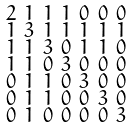Convert formula to latex. <formula><loc_0><loc_0><loc_500><loc_500>\begin{smallmatrix} 2 & 1 & 1 & 1 & 0 & 0 & 0 \\ 1 & 3 & 1 & 1 & 1 & 1 & 1 \\ 1 & 1 & 3 & 0 & 1 & 1 & 0 \\ 1 & 1 & 0 & 3 & 0 & 0 & 0 \\ 0 & 1 & 1 & 0 & 3 & 0 & 0 \\ 0 & 1 & 1 & 0 & 0 & 3 & 0 \\ 0 & 1 & 0 & 0 & 0 & 0 & 3 \end{smallmatrix}</formula> 